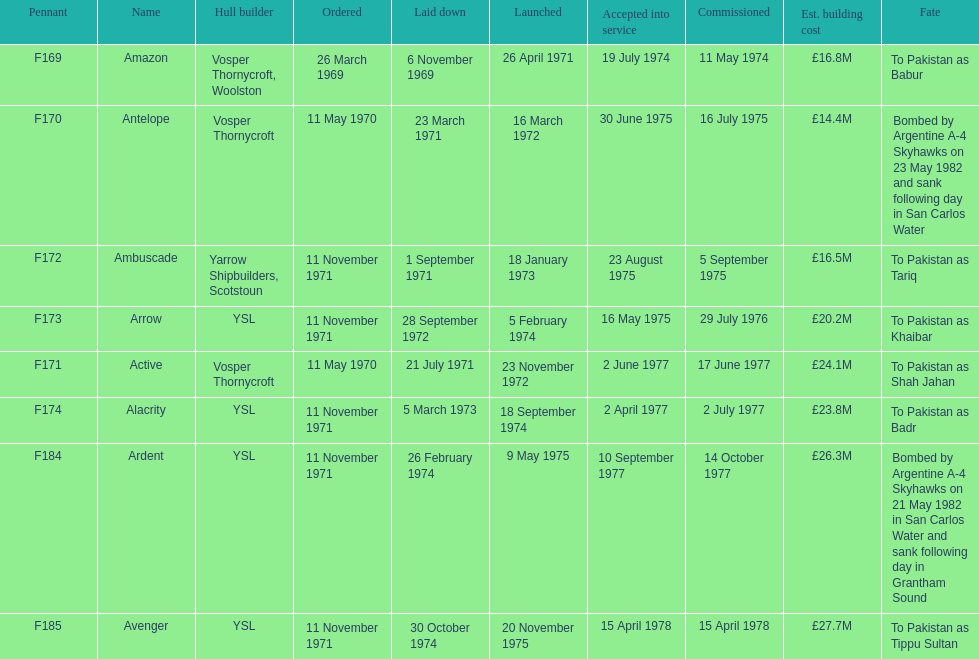What is the count of ships that were laid down during september? 2. 